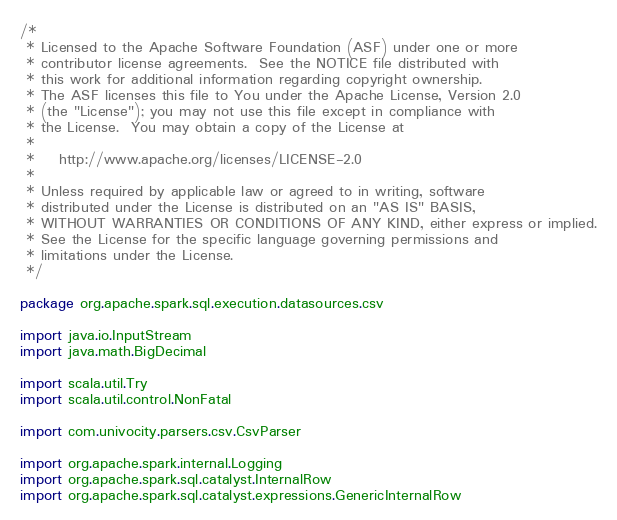<code> <loc_0><loc_0><loc_500><loc_500><_Scala_>/*
 * Licensed to the Apache Software Foundation (ASF) under one or more
 * contributor license agreements.  See the NOTICE file distributed with
 * this work for additional information regarding copyright ownership.
 * The ASF licenses this file to You under the Apache License, Version 2.0
 * (the "License"); you may not use this file except in compliance with
 * the License.  You may obtain a copy of the License at
 *
 *    http://www.apache.org/licenses/LICENSE-2.0
 *
 * Unless required by applicable law or agreed to in writing, software
 * distributed under the License is distributed on an "AS IS" BASIS,
 * WITHOUT WARRANTIES OR CONDITIONS OF ANY KIND, either express or implied.
 * See the License for the specific language governing permissions and
 * limitations under the License.
 */

package org.apache.spark.sql.execution.datasources.csv

import java.io.InputStream
import java.math.BigDecimal

import scala.util.Try
import scala.util.control.NonFatal

import com.univocity.parsers.csv.CsvParser

import org.apache.spark.internal.Logging
import org.apache.spark.sql.catalyst.InternalRow
import org.apache.spark.sql.catalyst.expressions.GenericInternalRow</code> 